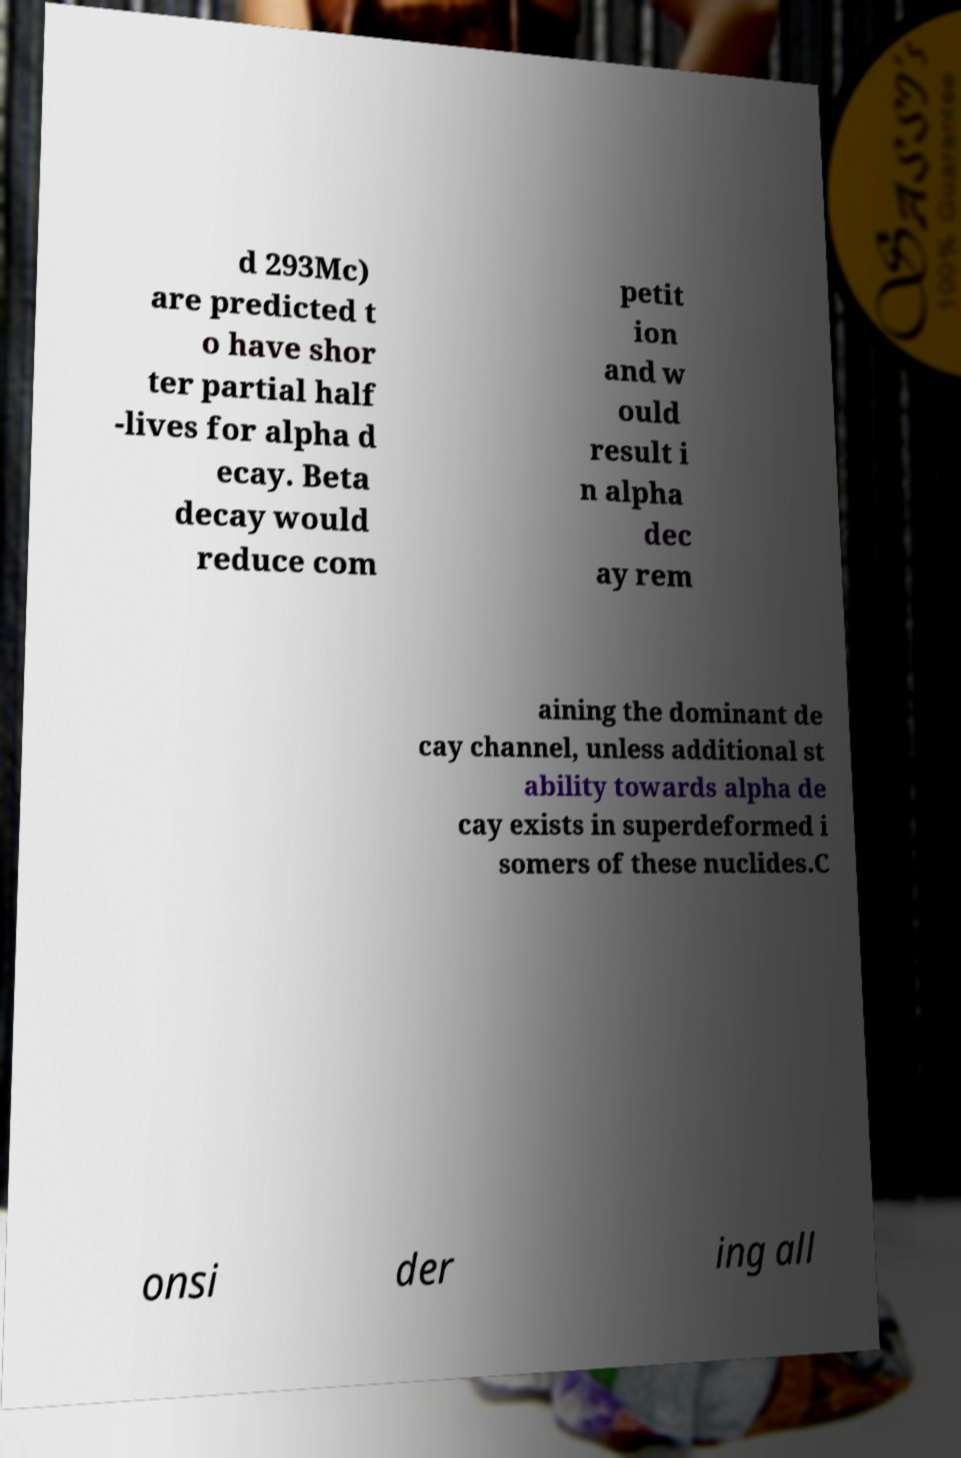Could you assist in decoding the text presented in this image and type it out clearly? d 293Mc) are predicted t o have shor ter partial half -lives for alpha d ecay. Beta decay would reduce com petit ion and w ould result i n alpha dec ay rem aining the dominant de cay channel, unless additional st ability towards alpha de cay exists in superdeformed i somers of these nuclides.C onsi der ing all 